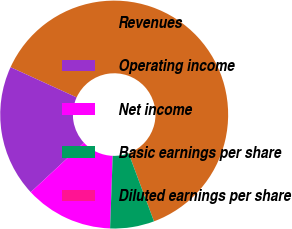Convert chart. <chart><loc_0><loc_0><loc_500><loc_500><pie_chart><fcel>Revenues<fcel>Operating income<fcel>Net income<fcel>Basic earnings per share<fcel>Diluted earnings per share<nl><fcel>62.5%<fcel>18.75%<fcel>12.5%<fcel>6.25%<fcel>0.0%<nl></chart> 